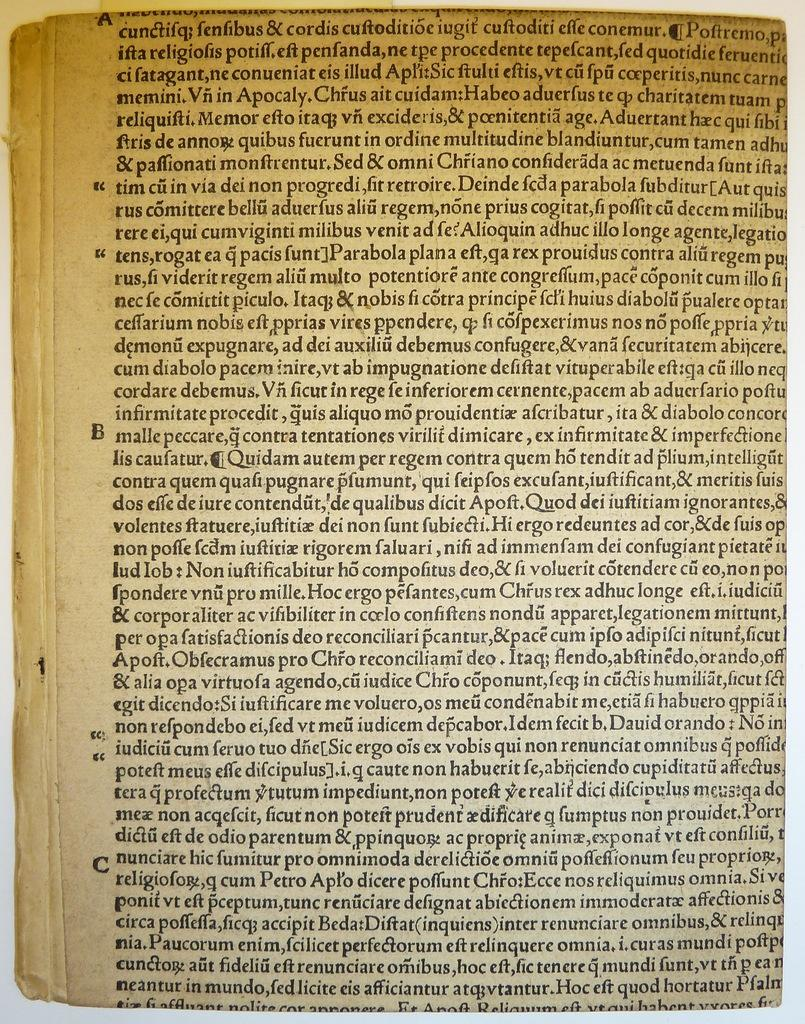<image>
Describe the image concisely. The page shown in the book starts with the word cunctifiq. 